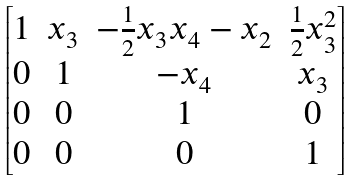<formula> <loc_0><loc_0><loc_500><loc_500>\begin{bmatrix} 1 & x _ { 3 } & - \frac { 1 } { 2 } x _ { 3 } x _ { 4 } - x _ { 2 } & \frac { 1 } { 2 } x _ { 3 } ^ { 2 } \\ 0 & 1 & - x _ { 4 } & x _ { 3 } \\ 0 & 0 & 1 & 0 \\ 0 & 0 & 0 & 1 \end{bmatrix}</formula> 